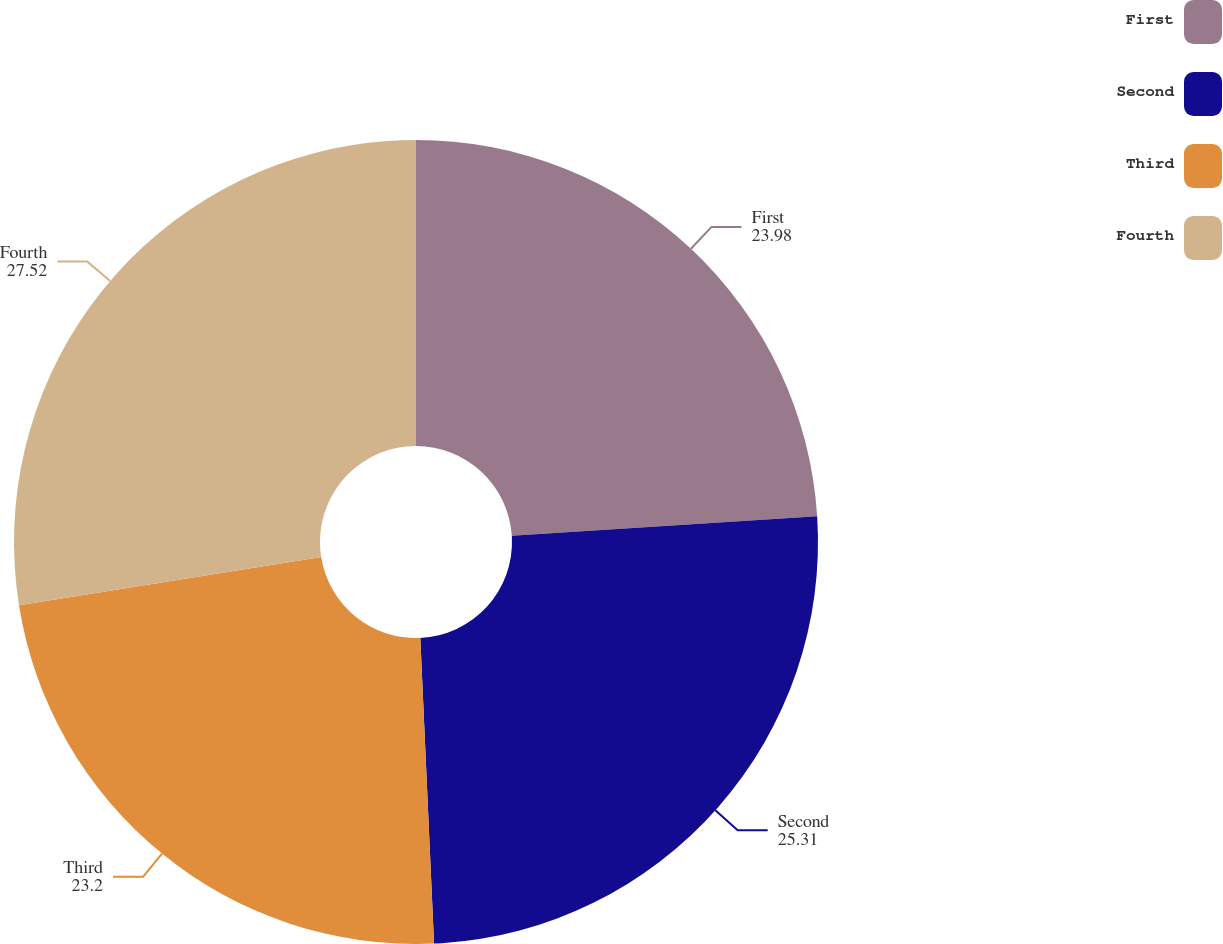Convert chart. <chart><loc_0><loc_0><loc_500><loc_500><pie_chart><fcel>First<fcel>Second<fcel>Third<fcel>Fourth<nl><fcel>23.98%<fcel>25.31%<fcel>23.2%<fcel>27.52%<nl></chart> 